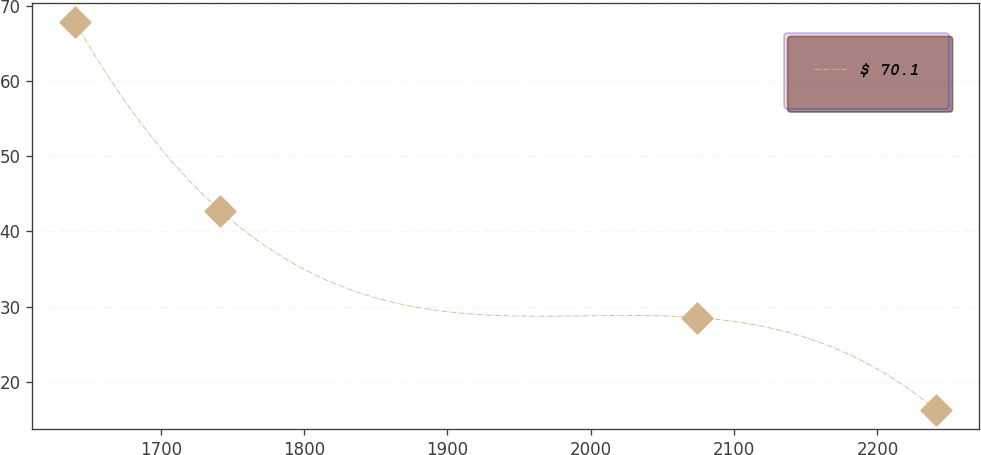Convert chart. <chart><loc_0><loc_0><loc_500><loc_500><line_chart><ecel><fcel>$ 70.1<nl><fcel>1640.43<fcel>67.8<nl><fcel>1741.61<fcel>42.76<nl><fcel>2073.98<fcel>28.55<nl><fcel>2241.07<fcel>16.27<nl></chart> 